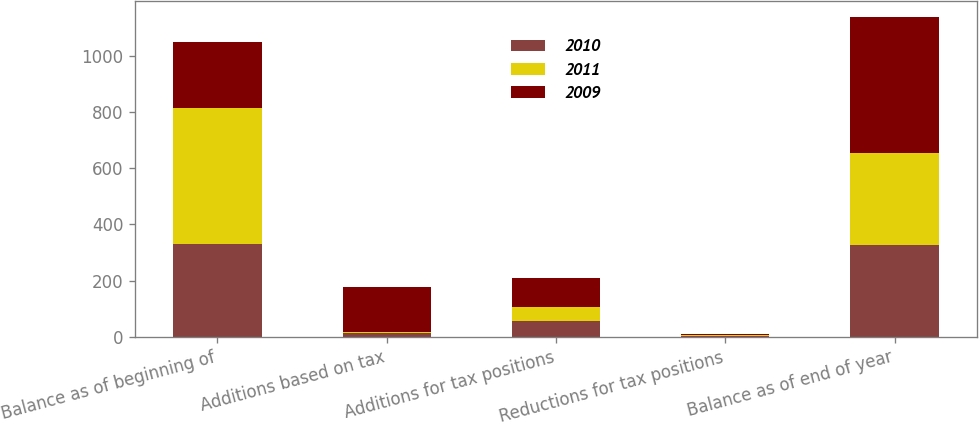Convert chart to OTSL. <chart><loc_0><loc_0><loc_500><loc_500><stacked_bar_chart><ecel><fcel>Balance as of beginning of<fcel>Additions based on tax<fcel>Additions for tax positions<fcel>Reductions for tax positions<fcel>Balance as of end of year<nl><fcel>2010<fcel>330<fcel>14<fcel>55<fcel>3<fcel>326<nl><fcel>2011<fcel>484<fcel>4<fcel>49<fcel>4<fcel>330<nl><fcel>2009<fcel>238<fcel>158<fcel>106<fcel>1<fcel>484<nl></chart> 